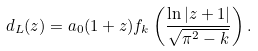Convert formula to latex. <formula><loc_0><loc_0><loc_500><loc_500>d _ { L } ( z ) = a _ { 0 } ( 1 + z ) f _ { k } \left ( \frac { \ln | z + 1 | } { \sqrt { \pi ^ { 2 } - k } } \right ) .</formula> 